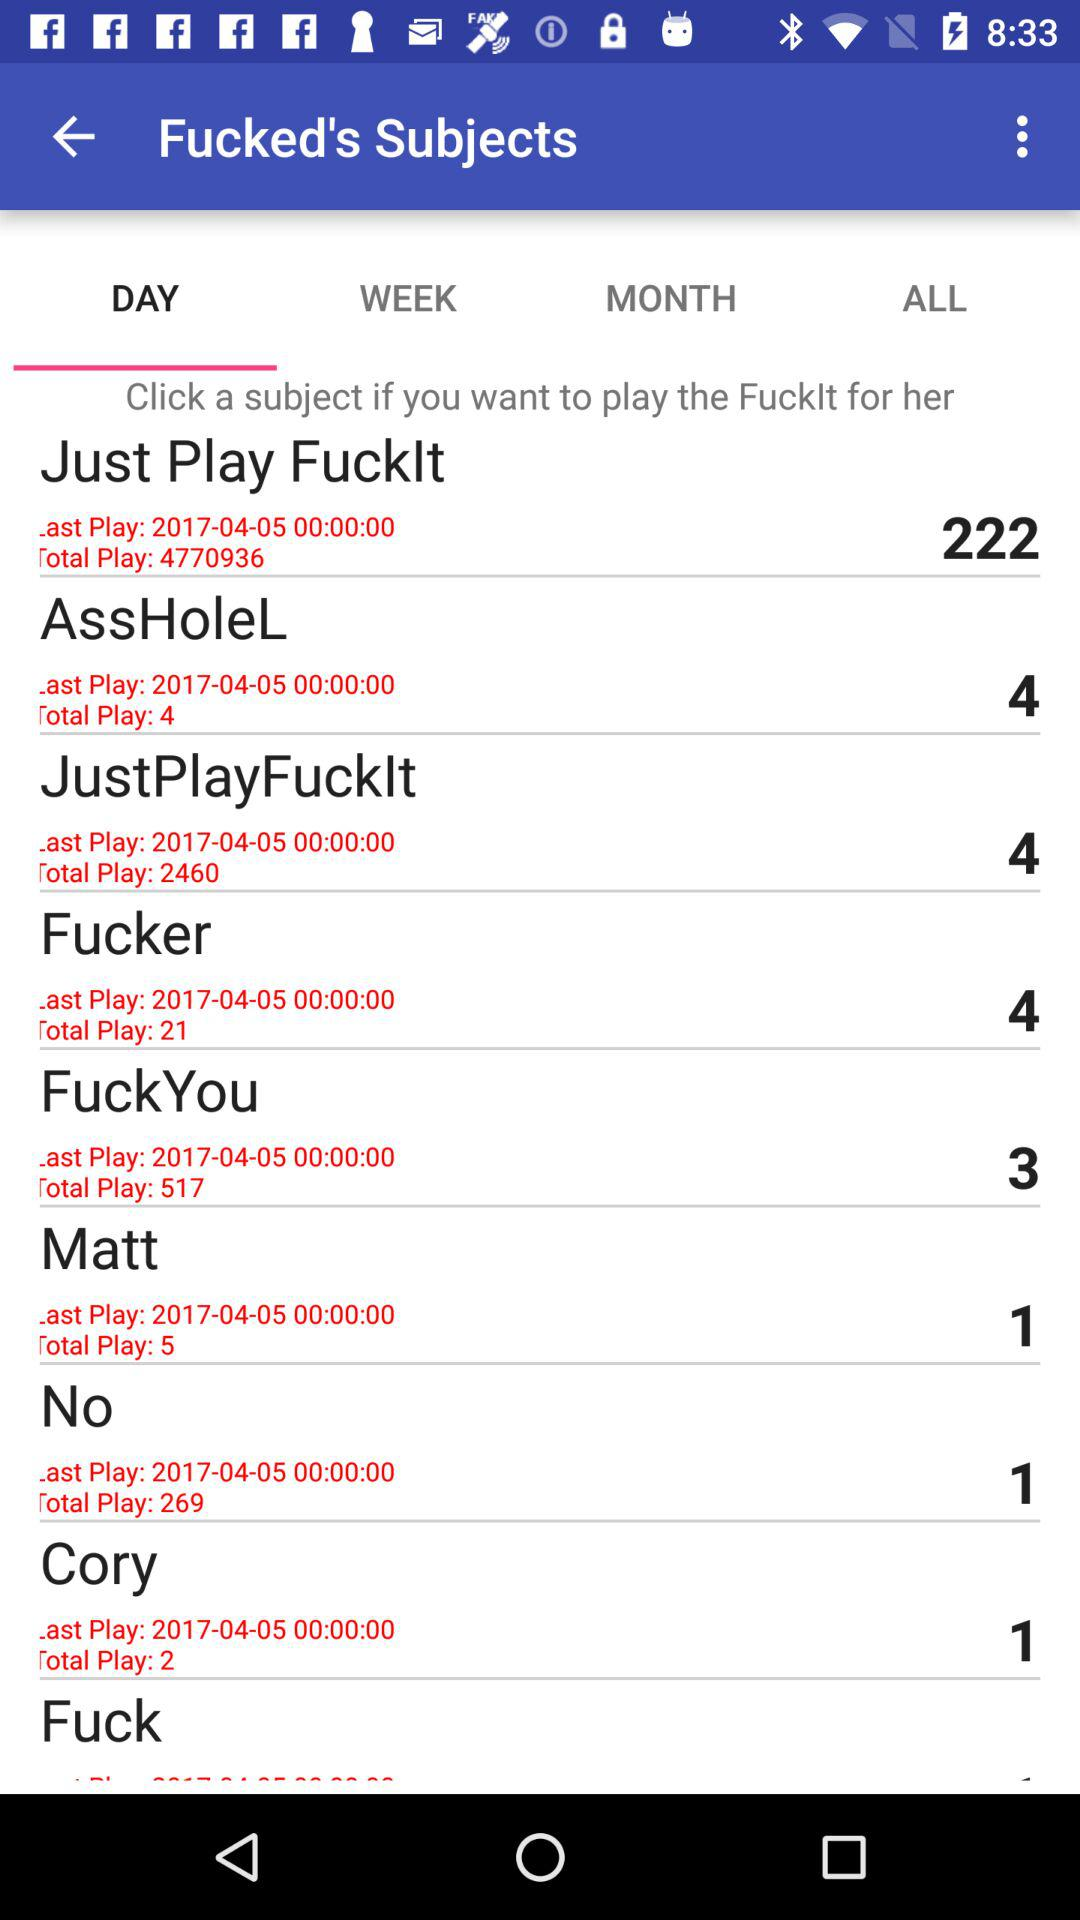Which is the selected tab? The selected tab is "DAY". 